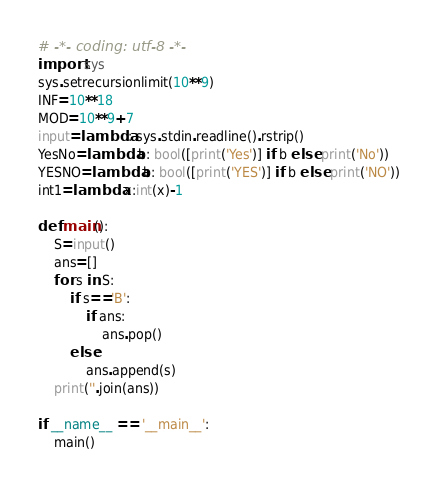<code> <loc_0><loc_0><loc_500><loc_500><_Python_># -*- coding: utf-8 -*-
import sys
sys.setrecursionlimit(10**9)
INF=10**18
MOD=10**9+7
input=lambda: sys.stdin.readline().rstrip()
YesNo=lambda b: bool([print('Yes')] if b else print('No'))
YESNO=lambda b: bool([print('YES')] if b else print('NO'))
int1=lambda x:int(x)-1

def main():
    S=input()
    ans=[]
    for s in S:
        if s=='B':
            if ans:
                ans.pop()
        else:
            ans.append(s)
    print(''.join(ans))

if __name__ == '__main__':
    main()
</code> 